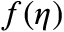<formula> <loc_0><loc_0><loc_500><loc_500>f ( \eta )</formula> 